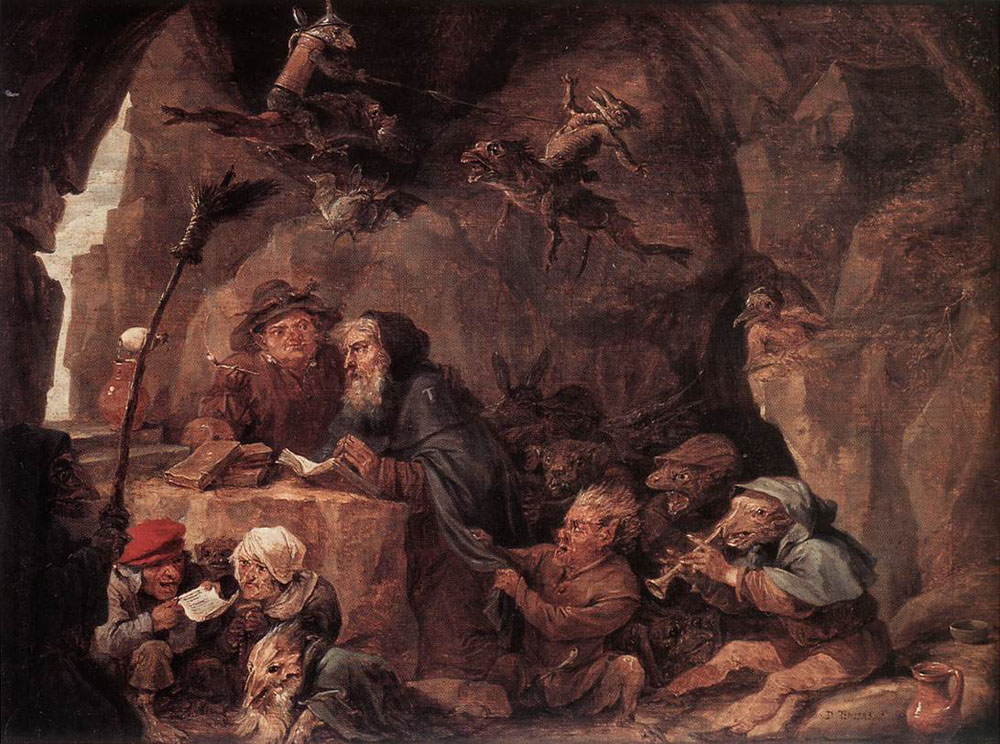Could you tell us more about the significance of the different activities the dwarves are engaged in within this painting? Certainly! Each dwarf's activity contributes to a narrative that reflects not just a moment in time but a tableau of community and culture. Those reading and discussing manuscripts could hint at a value placed on knowledge and tradition within their group. Meanwhile, those drinking and celebrating might suggest moments of leisure and communal bonding. Together, these activities offer a balanced portrayal of daily life within their secluded environment, showcasing both intellectual pursuits and the joy of social interactions. 